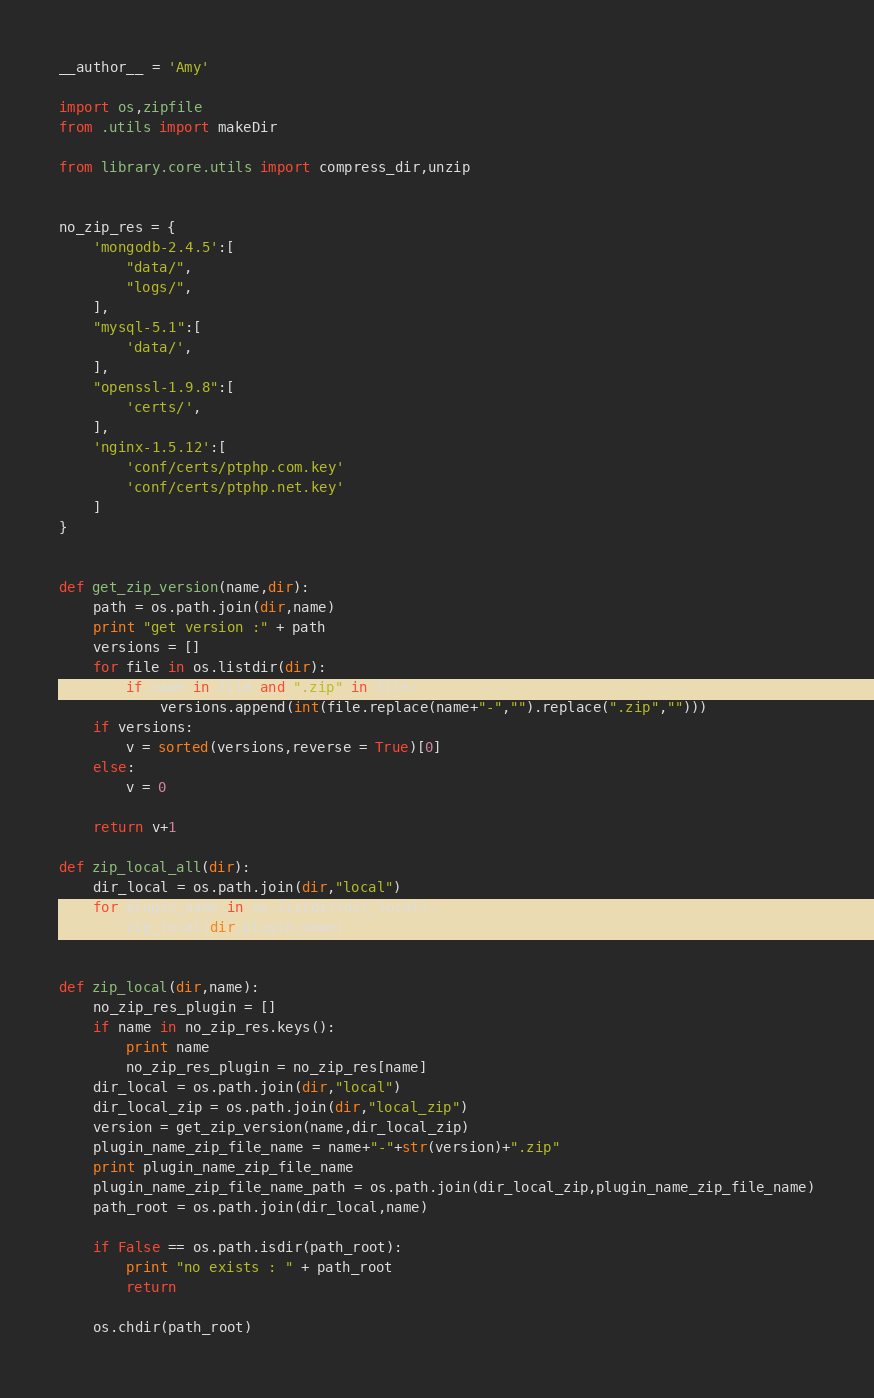Convert code to text. <code><loc_0><loc_0><loc_500><loc_500><_Python_>__author__ = 'Amy'

import os,zipfile
from .utils import makeDir

from library.core.utils import compress_dir,unzip


no_zip_res = {
    'mongodb-2.4.5':[
        "data/",
        "logs/",
    ],
    "mysql-5.1":[
        'data/',
    ],
    "openssl-1.9.8":[
        'certs/',
    ],
    'nginx-1.5.12':[
        'conf/certs/ptphp.com.key'
        'conf/certs/ptphp.net.key'
    ]
}


def get_zip_version(name,dir):
    path = os.path.join(dir,name)
    print "get version :" + path
    versions = []
    for file in os.listdir(dir):
        if name in file and ".zip" in file:
            versions.append(int(file.replace(name+"-","").replace(".zip","")))
    if versions:
        v = sorted(versions,reverse = True)[0]
    else:
        v = 0

    return v+1

def zip_local_all(dir):
    dir_local = os.path.join(dir,"local")
    for plugin_name in os.listdir(dir_local):
        zip_local(dir,plugin_name)


def zip_local(dir,name):
    no_zip_res_plugin = []
    if name in no_zip_res.keys():
        print name
        no_zip_res_plugin = no_zip_res[name]
    dir_local = os.path.join(dir,"local")
    dir_local_zip = os.path.join(dir,"local_zip")
    version = get_zip_version(name,dir_local_zip)
    plugin_name_zip_file_name = name+"-"+str(version)+".zip"
    print plugin_name_zip_file_name
    plugin_name_zip_file_name_path = os.path.join(dir_local_zip,plugin_name_zip_file_name)
    path_root = os.path.join(dir_local,name)

    if False == os.path.isdir(path_root):
        print "no exists : " + path_root
        return

    os.chdir(path_root)</code> 